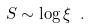<formula> <loc_0><loc_0><loc_500><loc_500>S \sim \log { \xi } \ .</formula> 